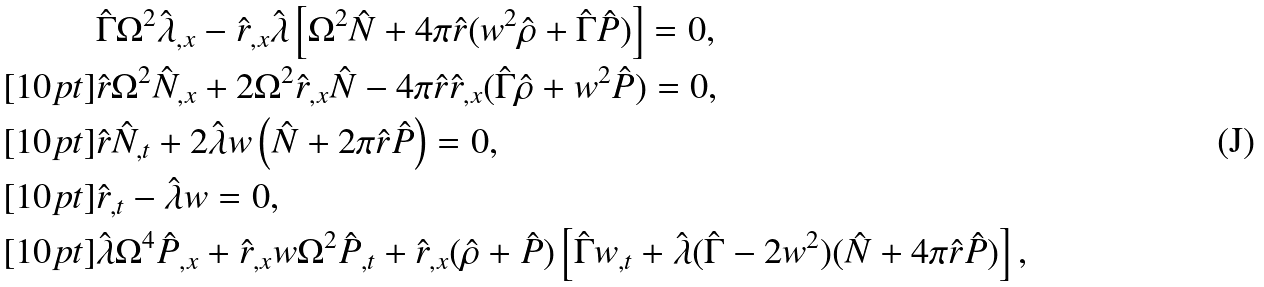<formula> <loc_0><loc_0><loc_500><loc_500>& \hat { \Gamma } \Omega ^ { 2 } \hat { \lambda } _ { , x } - \hat { r } _ { , x } \hat { \lambda } \left [ \Omega ^ { 2 } \hat { N } + 4 \pi \hat { r } ( w ^ { 2 } \hat { \rho } + \hat { \Gamma } \hat { P } ) \right ] = 0 , \\ [ 1 0 p t ] & \hat { r } \Omega ^ { 2 } \hat { N } _ { , x } + 2 \Omega ^ { 2 } \hat { r } _ { , x } \hat { N } - 4 \pi \hat { r } \hat { r } _ { , x } ( \hat { \Gamma } \hat { \rho } + w ^ { 2 } \hat { P } ) = 0 , \\ [ 1 0 p t ] & \hat { r } \hat { N } _ { , t } + 2 \hat { \lambda } w \left ( \hat { N } + 2 \pi \hat { r } \hat { P } \right ) = 0 , \\ [ 1 0 p t ] & \hat { r } _ { , t } - \hat { \lambda } w = 0 , \\ [ 1 0 p t ] & \hat { \lambda } \Omega ^ { 4 } \hat { P } _ { , x } + \hat { r } _ { , x } w \Omega ^ { 2 } \hat { P } _ { , t } + \hat { r } _ { , x } ( \hat { \rho } + \hat { P } ) \left [ \hat { \Gamma } w _ { , t } + \hat { \lambda } ( \hat { \Gamma } - 2 w ^ { 2 } ) ( \hat { N } + 4 \pi \hat { r } \hat { P } ) \right ] ,</formula> 